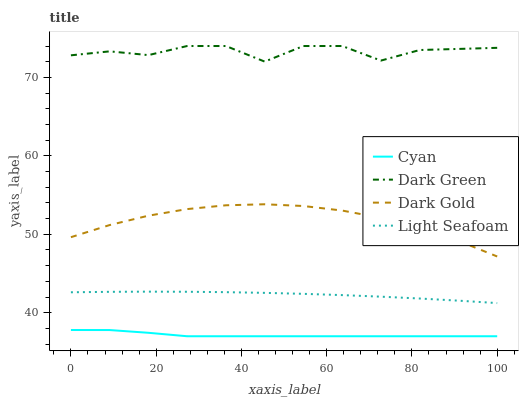Does Cyan have the minimum area under the curve?
Answer yes or no. Yes. Does Dark Green have the maximum area under the curve?
Answer yes or no. Yes. Does Dark Gold have the minimum area under the curve?
Answer yes or no. No. Does Dark Gold have the maximum area under the curve?
Answer yes or no. No. Is Light Seafoam the smoothest?
Answer yes or no. Yes. Is Dark Green the roughest?
Answer yes or no. Yes. Is Dark Gold the smoothest?
Answer yes or no. No. Is Dark Gold the roughest?
Answer yes or no. No. Does Dark Gold have the lowest value?
Answer yes or no. No. Does Dark Green have the highest value?
Answer yes or no. Yes. Does Dark Gold have the highest value?
Answer yes or no. No. Is Cyan less than Dark Green?
Answer yes or no. Yes. Is Dark Green greater than Light Seafoam?
Answer yes or no. Yes. Does Cyan intersect Dark Green?
Answer yes or no. No. 